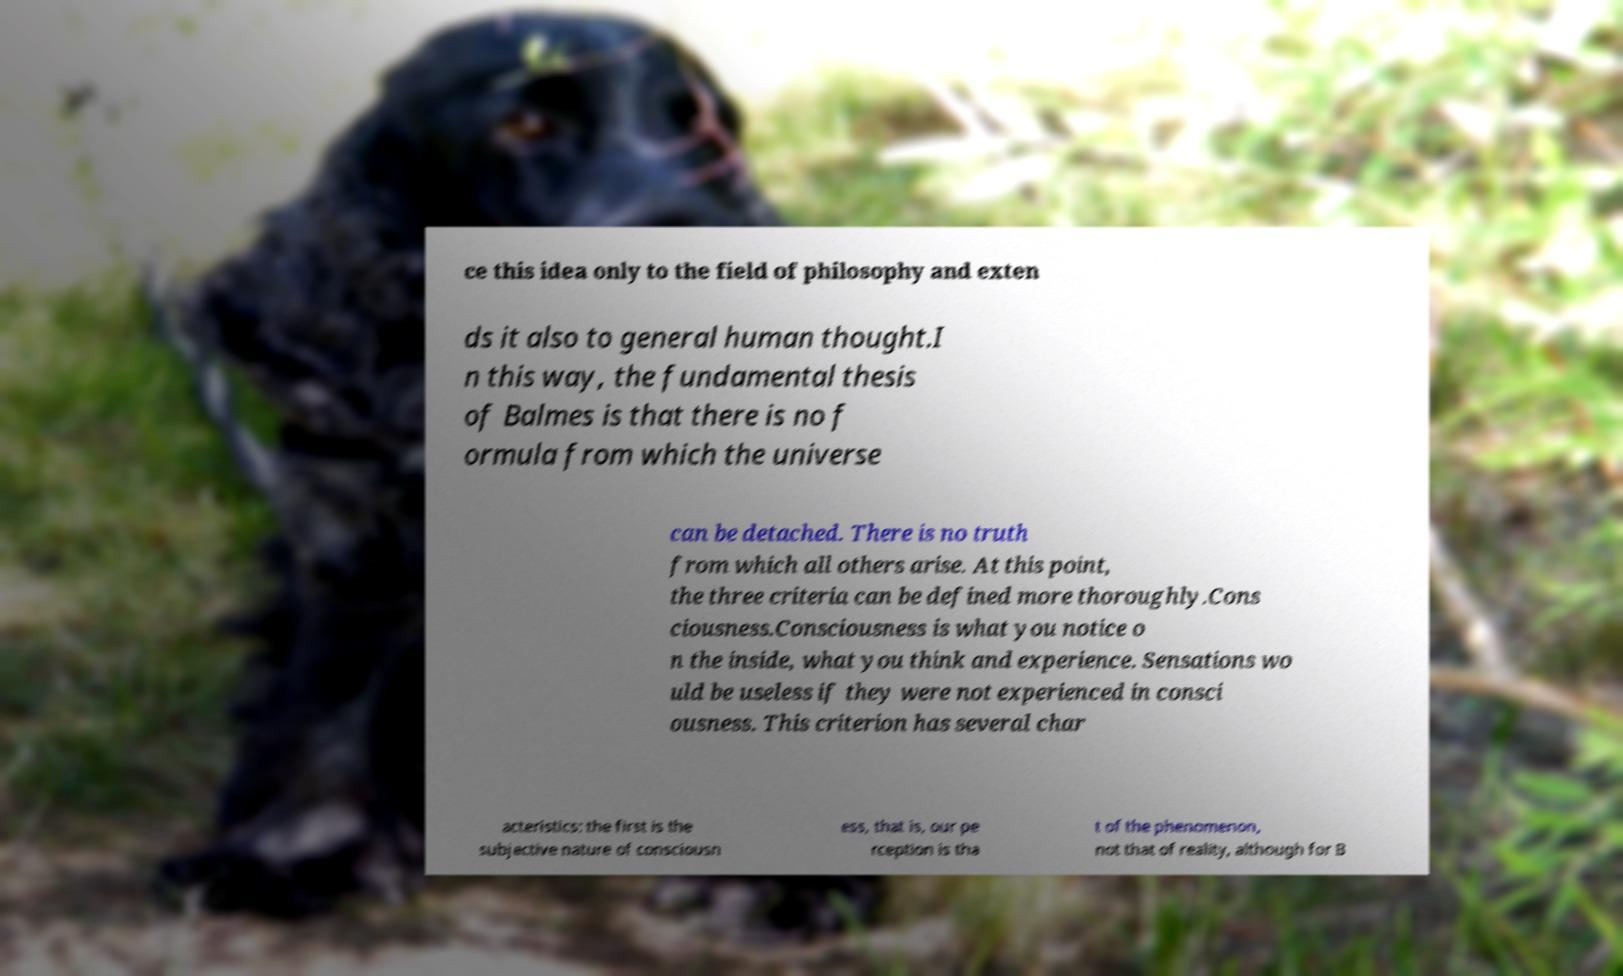For documentation purposes, I need the text within this image transcribed. Could you provide that? ce this idea only to the field of philosophy and exten ds it also to general human thought.I n this way, the fundamental thesis of Balmes is that there is no f ormula from which the universe can be detached. There is no truth from which all others arise. At this point, the three criteria can be defined more thoroughly.Cons ciousness.Consciousness is what you notice o n the inside, what you think and experience. Sensations wo uld be useless if they were not experienced in consci ousness. This criterion has several char acteristics: the first is the subjective nature of consciousn ess, that is, our pe rception is tha t of the phenomenon, not that of reality, although for B 